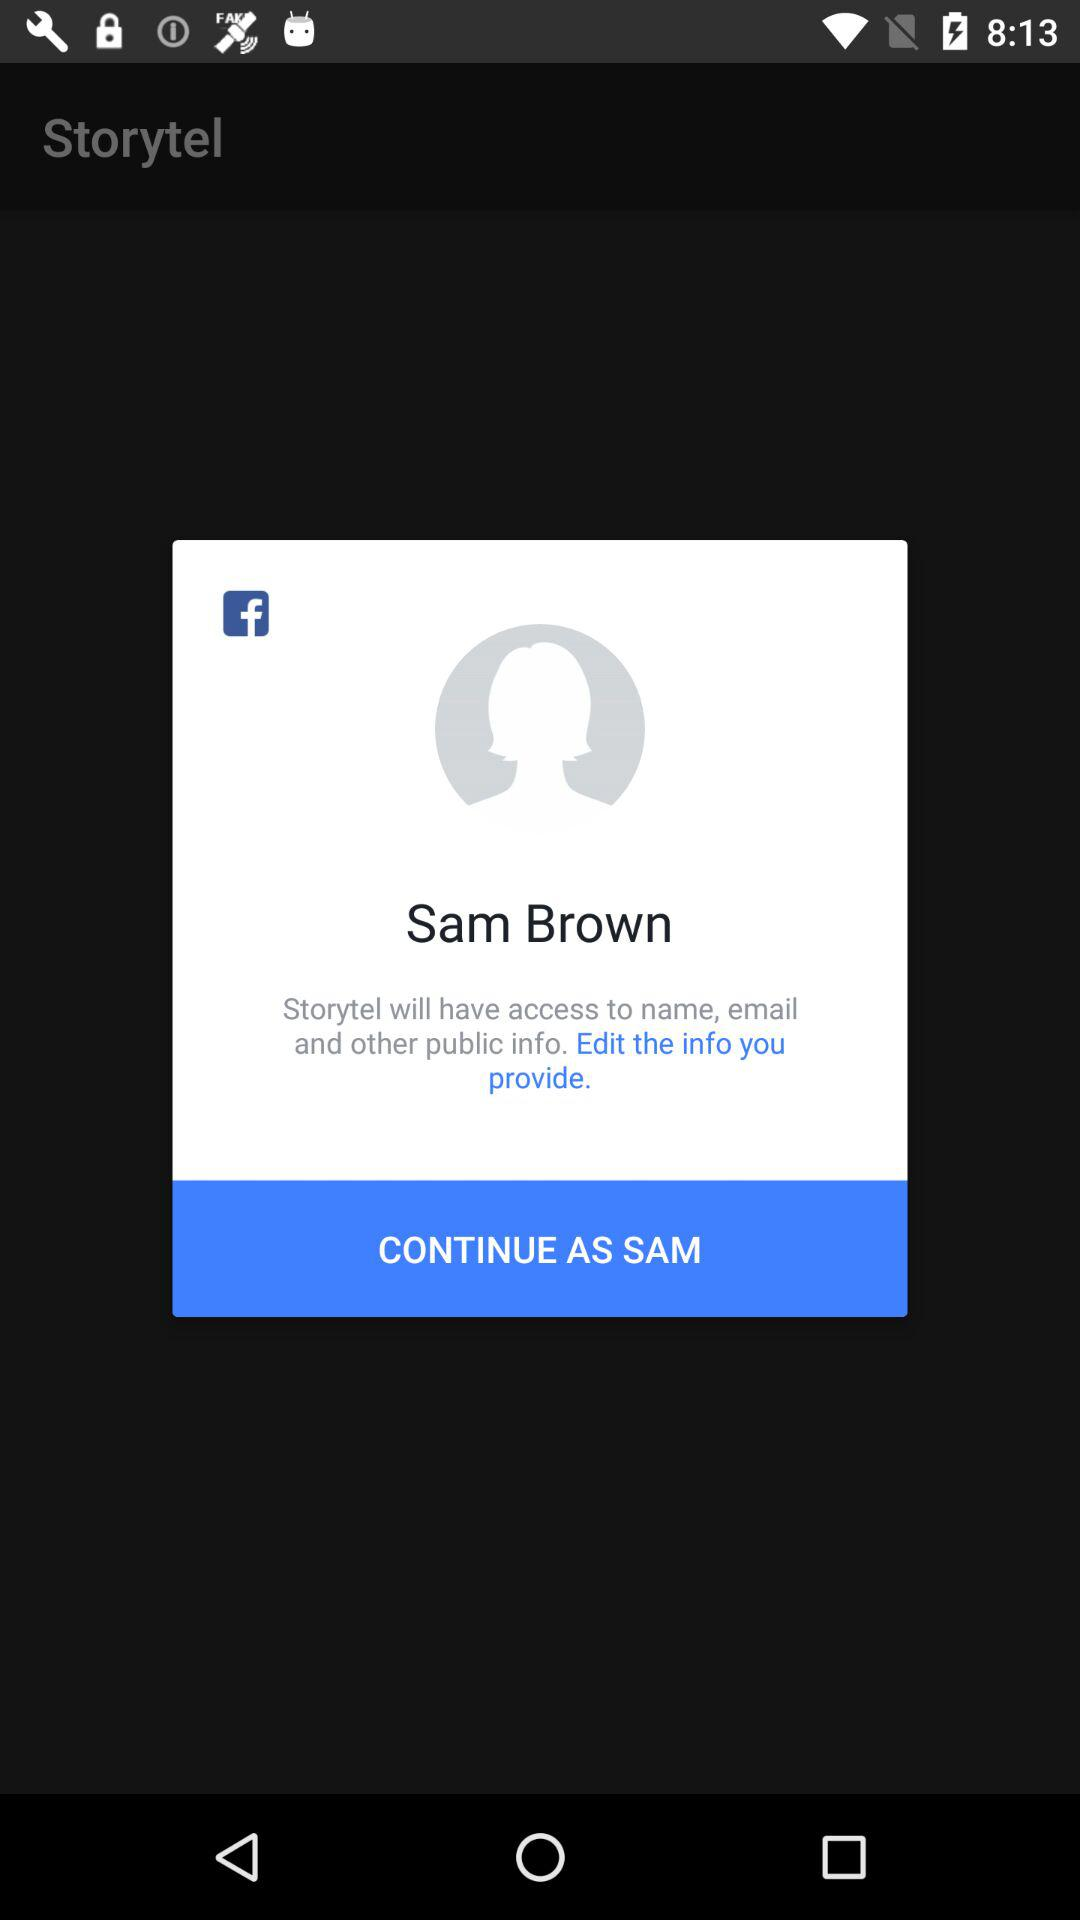How many public information types does Storytel have access to?
Answer the question using a single word or phrase. 3 